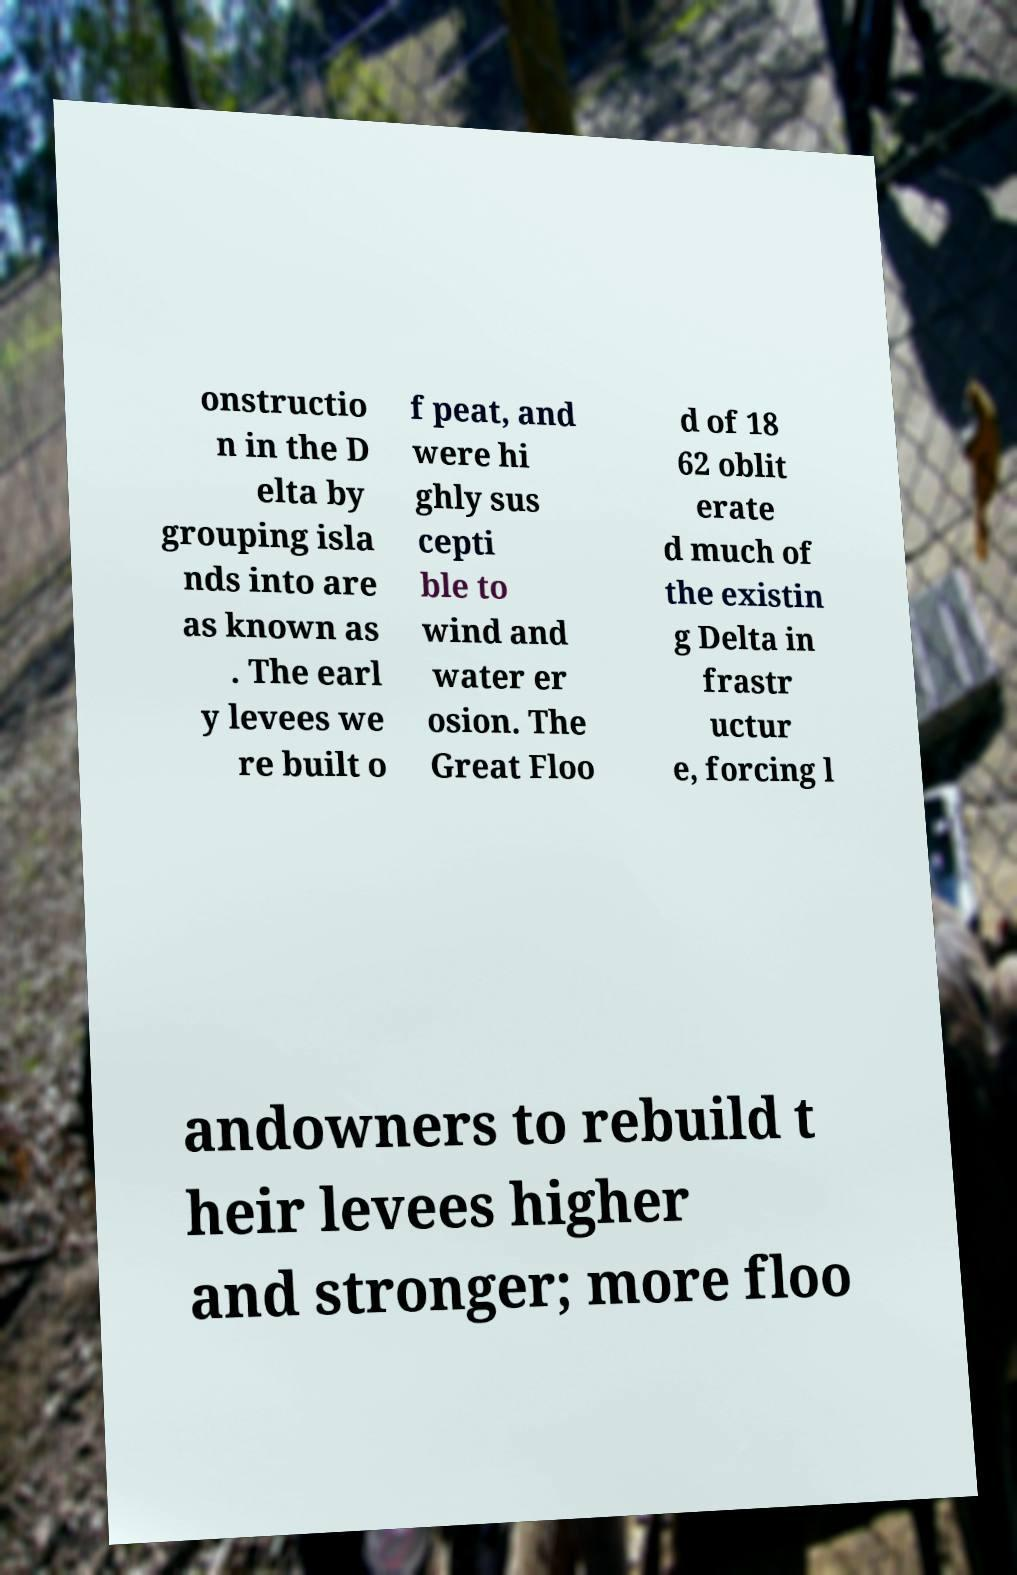There's text embedded in this image that I need extracted. Can you transcribe it verbatim? onstructio n in the D elta by grouping isla nds into are as known as . The earl y levees we re built o f peat, and were hi ghly sus cepti ble to wind and water er osion. The Great Floo d of 18 62 oblit erate d much of the existin g Delta in frastr uctur e, forcing l andowners to rebuild t heir levees higher and stronger; more floo 